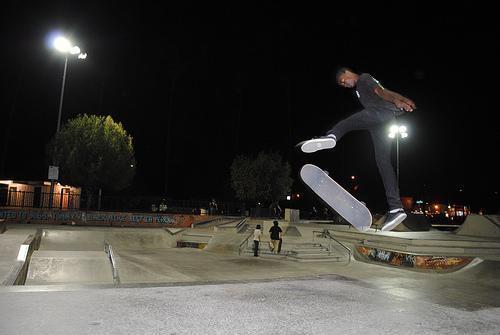How many people are there?
Give a very brief answer. 3. How many sets of lights are there?
Give a very brief answer. 2. 